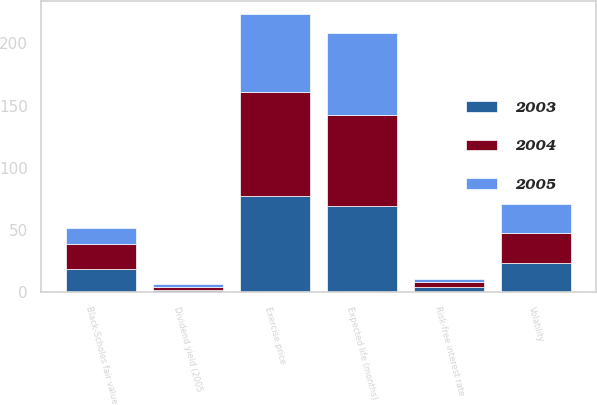Convert chart to OTSL. <chart><loc_0><loc_0><loc_500><loc_500><stacked_bar_chart><ecel><fcel>Exercise price<fcel>Risk-free interest rate<fcel>Dividend yield (2005<fcel>Volatility<fcel>Expected life (months)<fcel>Black-Scholes fair value<nl><fcel>2003<fcel>76.87<fcel>4<fcel>2<fcel>23.5<fcel>69<fcel>18.28<nl><fcel>2004<fcel>84.39<fcel>4.1<fcel>2.2<fcel>23.8<fcel>73<fcel>20.3<nl><fcel>2005<fcel>61.91<fcel>2.6<fcel>2.1<fcel>23.8<fcel>66<fcel>12.75<nl></chart> 